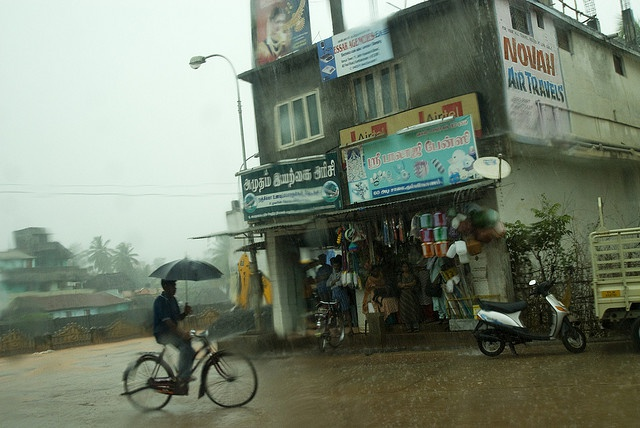Describe the objects in this image and their specific colors. I can see bicycle in ivory, gray, and black tones, truck in ivory, olive, black, and darkgreen tones, motorcycle in ivory, black, gray, darkgray, and beige tones, people in ivory, black, gray, and darkgray tones, and people in ivory, black, darkgreen, and gray tones in this image. 